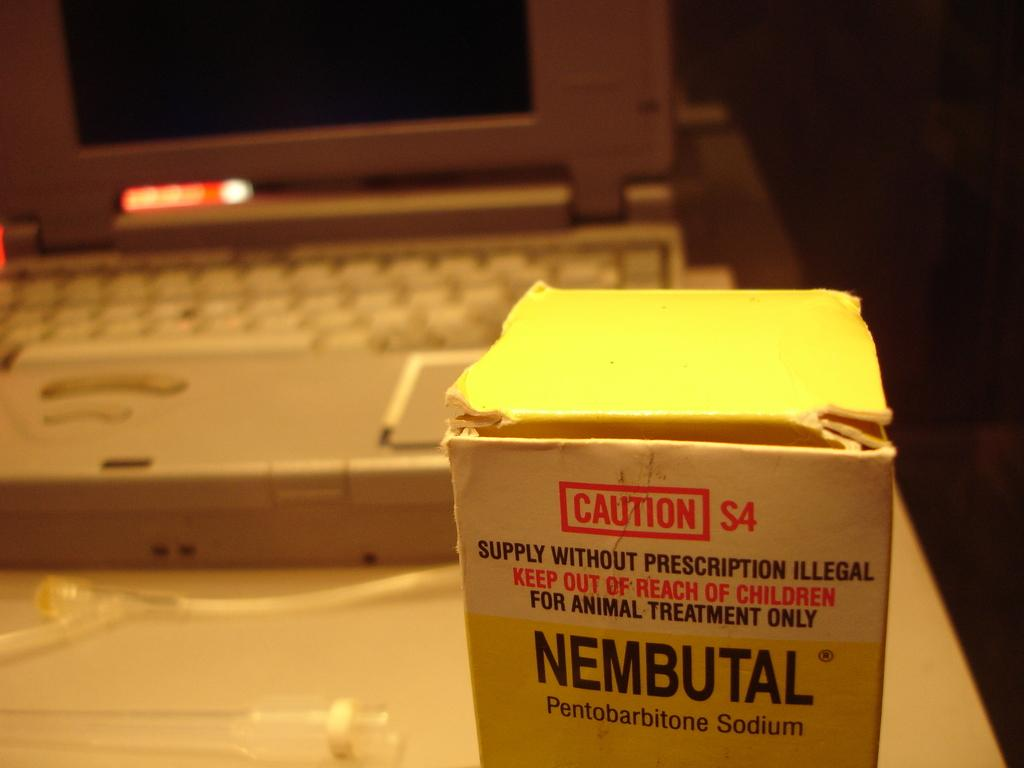<image>
Render a clear and concise summary of the photo. A white box of Nembutal Pentobarbitone Sodium in front of a laptop. 